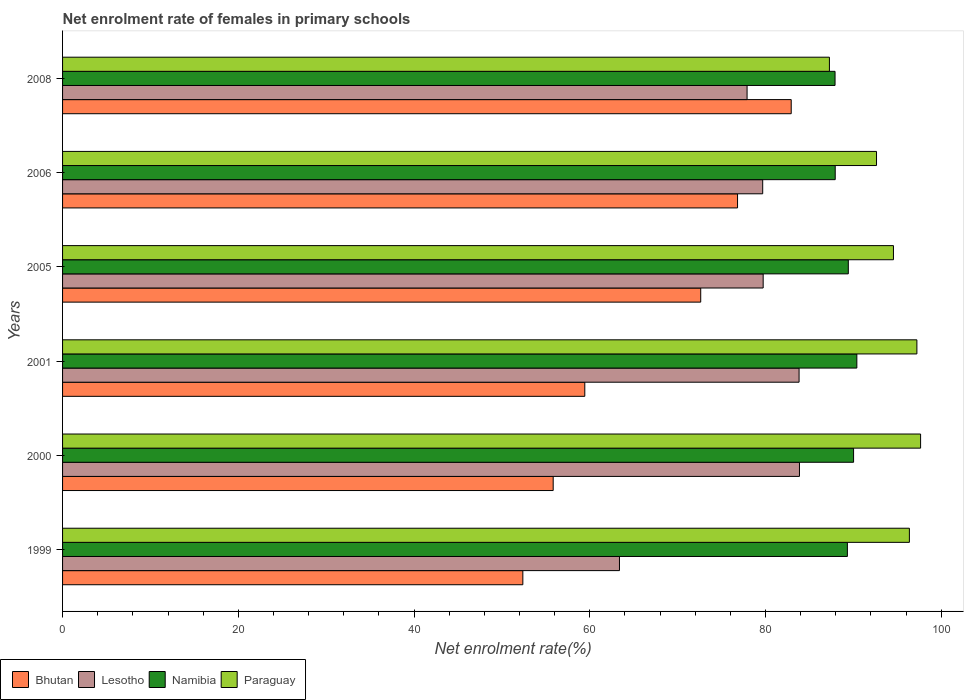How many different coloured bars are there?
Provide a succinct answer. 4. Are the number of bars on each tick of the Y-axis equal?
Provide a short and direct response. Yes. What is the label of the 6th group of bars from the top?
Make the answer very short. 1999. What is the net enrolment rate of females in primary schools in Paraguay in 1999?
Provide a succinct answer. 96.38. Across all years, what is the maximum net enrolment rate of females in primary schools in Namibia?
Make the answer very short. 90.4. Across all years, what is the minimum net enrolment rate of females in primary schools in Lesotho?
Make the answer very short. 63.38. In which year was the net enrolment rate of females in primary schools in Namibia maximum?
Keep it short and to the point. 2001. What is the total net enrolment rate of females in primary schools in Namibia in the graph?
Provide a short and direct response. 535.02. What is the difference between the net enrolment rate of females in primary schools in Bhutan in 1999 and that in 2001?
Offer a terse response. -7.05. What is the difference between the net enrolment rate of females in primary schools in Bhutan in 2006 and the net enrolment rate of females in primary schools in Paraguay in 2000?
Make the answer very short. -20.83. What is the average net enrolment rate of females in primary schools in Lesotho per year?
Your answer should be very brief. 78.07. In the year 1999, what is the difference between the net enrolment rate of females in primary schools in Bhutan and net enrolment rate of females in primary schools in Paraguay?
Your response must be concise. -43.99. What is the ratio of the net enrolment rate of females in primary schools in Paraguay in 2000 to that in 2006?
Offer a very short reply. 1.05. Is the difference between the net enrolment rate of females in primary schools in Bhutan in 2000 and 2001 greater than the difference between the net enrolment rate of females in primary schools in Paraguay in 2000 and 2001?
Your response must be concise. No. What is the difference between the highest and the second highest net enrolment rate of females in primary schools in Bhutan?
Offer a terse response. 6.11. What is the difference between the highest and the lowest net enrolment rate of females in primary schools in Bhutan?
Your answer should be compact. 30.54. Is the sum of the net enrolment rate of females in primary schools in Lesotho in 2000 and 2005 greater than the maximum net enrolment rate of females in primary schools in Paraguay across all years?
Give a very brief answer. Yes. Is it the case that in every year, the sum of the net enrolment rate of females in primary schools in Namibia and net enrolment rate of females in primary schools in Bhutan is greater than the sum of net enrolment rate of females in primary schools in Lesotho and net enrolment rate of females in primary schools in Paraguay?
Give a very brief answer. No. What does the 2nd bar from the top in 2006 represents?
Provide a short and direct response. Namibia. What does the 4th bar from the bottom in 2000 represents?
Offer a very short reply. Paraguay. How many years are there in the graph?
Give a very brief answer. 6. Are the values on the major ticks of X-axis written in scientific E-notation?
Your answer should be compact. No. Does the graph contain any zero values?
Keep it short and to the point. No. Where does the legend appear in the graph?
Make the answer very short. Bottom left. What is the title of the graph?
Provide a short and direct response. Net enrolment rate of females in primary schools. What is the label or title of the X-axis?
Provide a succinct answer. Net enrolment rate(%). What is the Net enrolment rate(%) of Bhutan in 1999?
Give a very brief answer. 52.39. What is the Net enrolment rate(%) in Lesotho in 1999?
Your answer should be very brief. 63.38. What is the Net enrolment rate(%) in Namibia in 1999?
Offer a very short reply. 89.32. What is the Net enrolment rate(%) of Paraguay in 1999?
Ensure brevity in your answer.  96.38. What is the Net enrolment rate(%) of Bhutan in 2000?
Keep it short and to the point. 55.84. What is the Net enrolment rate(%) of Lesotho in 2000?
Offer a very short reply. 83.87. What is the Net enrolment rate(%) in Namibia in 2000?
Keep it short and to the point. 90.03. What is the Net enrolment rate(%) of Paraguay in 2000?
Give a very brief answer. 97.65. What is the Net enrolment rate(%) of Bhutan in 2001?
Give a very brief answer. 59.44. What is the Net enrolment rate(%) of Lesotho in 2001?
Your answer should be compact. 83.82. What is the Net enrolment rate(%) of Namibia in 2001?
Offer a terse response. 90.4. What is the Net enrolment rate(%) in Paraguay in 2001?
Your answer should be compact. 97.23. What is the Net enrolment rate(%) of Bhutan in 2005?
Offer a terse response. 72.63. What is the Net enrolment rate(%) of Lesotho in 2005?
Your response must be concise. 79.74. What is the Net enrolment rate(%) of Namibia in 2005?
Provide a short and direct response. 89.43. What is the Net enrolment rate(%) of Paraguay in 2005?
Offer a very short reply. 94.56. What is the Net enrolment rate(%) of Bhutan in 2006?
Provide a short and direct response. 76.82. What is the Net enrolment rate(%) of Lesotho in 2006?
Give a very brief answer. 79.68. What is the Net enrolment rate(%) in Namibia in 2006?
Your response must be concise. 87.94. What is the Net enrolment rate(%) of Paraguay in 2006?
Ensure brevity in your answer.  92.64. What is the Net enrolment rate(%) in Bhutan in 2008?
Offer a very short reply. 82.93. What is the Net enrolment rate(%) of Lesotho in 2008?
Keep it short and to the point. 77.91. What is the Net enrolment rate(%) in Namibia in 2008?
Make the answer very short. 87.92. What is the Net enrolment rate(%) in Paraguay in 2008?
Your response must be concise. 87.28. Across all years, what is the maximum Net enrolment rate(%) in Bhutan?
Provide a succinct answer. 82.93. Across all years, what is the maximum Net enrolment rate(%) in Lesotho?
Your answer should be compact. 83.87. Across all years, what is the maximum Net enrolment rate(%) in Namibia?
Provide a short and direct response. 90.4. Across all years, what is the maximum Net enrolment rate(%) in Paraguay?
Your response must be concise. 97.65. Across all years, what is the minimum Net enrolment rate(%) of Bhutan?
Your response must be concise. 52.39. Across all years, what is the minimum Net enrolment rate(%) in Lesotho?
Offer a very short reply. 63.38. Across all years, what is the minimum Net enrolment rate(%) in Namibia?
Offer a very short reply. 87.92. Across all years, what is the minimum Net enrolment rate(%) in Paraguay?
Your response must be concise. 87.28. What is the total Net enrolment rate(%) of Bhutan in the graph?
Ensure brevity in your answer.  400.04. What is the total Net enrolment rate(%) of Lesotho in the graph?
Your answer should be very brief. 468.4. What is the total Net enrolment rate(%) of Namibia in the graph?
Ensure brevity in your answer.  535.02. What is the total Net enrolment rate(%) in Paraguay in the graph?
Your answer should be very brief. 565.74. What is the difference between the Net enrolment rate(%) in Bhutan in 1999 and that in 2000?
Your answer should be very brief. -3.45. What is the difference between the Net enrolment rate(%) of Lesotho in 1999 and that in 2000?
Provide a short and direct response. -20.48. What is the difference between the Net enrolment rate(%) in Namibia in 1999 and that in 2000?
Make the answer very short. -0.7. What is the difference between the Net enrolment rate(%) in Paraguay in 1999 and that in 2000?
Your response must be concise. -1.27. What is the difference between the Net enrolment rate(%) in Bhutan in 1999 and that in 2001?
Provide a short and direct response. -7.05. What is the difference between the Net enrolment rate(%) of Lesotho in 1999 and that in 2001?
Ensure brevity in your answer.  -20.44. What is the difference between the Net enrolment rate(%) of Namibia in 1999 and that in 2001?
Ensure brevity in your answer.  -1.08. What is the difference between the Net enrolment rate(%) of Paraguay in 1999 and that in 2001?
Make the answer very short. -0.85. What is the difference between the Net enrolment rate(%) of Bhutan in 1999 and that in 2005?
Give a very brief answer. -20.24. What is the difference between the Net enrolment rate(%) of Lesotho in 1999 and that in 2005?
Offer a terse response. -16.35. What is the difference between the Net enrolment rate(%) of Namibia in 1999 and that in 2005?
Provide a short and direct response. -0.1. What is the difference between the Net enrolment rate(%) in Paraguay in 1999 and that in 2005?
Keep it short and to the point. 1.81. What is the difference between the Net enrolment rate(%) in Bhutan in 1999 and that in 2006?
Ensure brevity in your answer.  -24.43. What is the difference between the Net enrolment rate(%) in Lesotho in 1999 and that in 2006?
Make the answer very short. -16.3. What is the difference between the Net enrolment rate(%) in Namibia in 1999 and that in 2006?
Provide a short and direct response. 1.39. What is the difference between the Net enrolment rate(%) in Paraguay in 1999 and that in 2006?
Keep it short and to the point. 3.74. What is the difference between the Net enrolment rate(%) in Bhutan in 1999 and that in 2008?
Ensure brevity in your answer.  -30.54. What is the difference between the Net enrolment rate(%) of Lesotho in 1999 and that in 2008?
Keep it short and to the point. -14.52. What is the difference between the Net enrolment rate(%) in Namibia in 1999 and that in 2008?
Offer a very short reply. 1.41. What is the difference between the Net enrolment rate(%) of Paraguay in 1999 and that in 2008?
Provide a short and direct response. 9.1. What is the difference between the Net enrolment rate(%) of Bhutan in 2000 and that in 2001?
Your answer should be compact. -3.6. What is the difference between the Net enrolment rate(%) in Lesotho in 2000 and that in 2001?
Give a very brief answer. 0.04. What is the difference between the Net enrolment rate(%) of Namibia in 2000 and that in 2001?
Your answer should be compact. -0.37. What is the difference between the Net enrolment rate(%) in Paraguay in 2000 and that in 2001?
Offer a very short reply. 0.42. What is the difference between the Net enrolment rate(%) in Bhutan in 2000 and that in 2005?
Give a very brief answer. -16.79. What is the difference between the Net enrolment rate(%) in Lesotho in 2000 and that in 2005?
Provide a succinct answer. 4.13. What is the difference between the Net enrolment rate(%) of Namibia in 2000 and that in 2005?
Your response must be concise. 0.6. What is the difference between the Net enrolment rate(%) of Paraguay in 2000 and that in 2005?
Your response must be concise. 3.09. What is the difference between the Net enrolment rate(%) of Bhutan in 2000 and that in 2006?
Provide a succinct answer. -20.98. What is the difference between the Net enrolment rate(%) in Lesotho in 2000 and that in 2006?
Provide a succinct answer. 4.18. What is the difference between the Net enrolment rate(%) in Namibia in 2000 and that in 2006?
Offer a very short reply. 2.09. What is the difference between the Net enrolment rate(%) of Paraguay in 2000 and that in 2006?
Your response must be concise. 5.02. What is the difference between the Net enrolment rate(%) of Bhutan in 2000 and that in 2008?
Provide a short and direct response. -27.09. What is the difference between the Net enrolment rate(%) of Lesotho in 2000 and that in 2008?
Your answer should be very brief. 5.96. What is the difference between the Net enrolment rate(%) of Namibia in 2000 and that in 2008?
Provide a succinct answer. 2.11. What is the difference between the Net enrolment rate(%) of Paraguay in 2000 and that in 2008?
Provide a short and direct response. 10.38. What is the difference between the Net enrolment rate(%) of Bhutan in 2001 and that in 2005?
Offer a terse response. -13.19. What is the difference between the Net enrolment rate(%) of Lesotho in 2001 and that in 2005?
Your answer should be very brief. 4.09. What is the difference between the Net enrolment rate(%) of Namibia in 2001 and that in 2005?
Your answer should be compact. 0.97. What is the difference between the Net enrolment rate(%) in Paraguay in 2001 and that in 2005?
Give a very brief answer. 2.67. What is the difference between the Net enrolment rate(%) in Bhutan in 2001 and that in 2006?
Ensure brevity in your answer.  -17.38. What is the difference between the Net enrolment rate(%) of Lesotho in 2001 and that in 2006?
Your answer should be very brief. 4.14. What is the difference between the Net enrolment rate(%) of Namibia in 2001 and that in 2006?
Give a very brief answer. 2.46. What is the difference between the Net enrolment rate(%) of Paraguay in 2001 and that in 2006?
Your answer should be compact. 4.59. What is the difference between the Net enrolment rate(%) of Bhutan in 2001 and that in 2008?
Offer a terse response. -23.49. What is the difference between the Net enrolment rate(%) in Lesotho in 2001 and that in 2008?
Provide a succinct answer. 5.92. What is the difference between the Net enrolment rate(%) in Namibia in 2001 and that in 2008?
Your response must be concise. 2.48. What is the difference between the Net enrolment rate(%) in Paraguay in 2001 and that in 2008?
Make the answer very short. 9.95. What is the difference between the Net enrolment rate(%) of Bhutan in 2005 and that in 2006?
Your answer should be very brief. -4.19. What is the difference between the Net enrolment rate(%) in Lesotho in 2005 and that in 2006?
Offer a terse response. 0.05. What is the difference between the Net enrolment rate(%) in Namibia in 2005 and that in 2006?
Give a very brief answer. 1.49. What is the difference between the Net enrolment rate(%) in Paraguay in 2005 and that in 2006?
Offer a terse response. 1.93. What is the difference between the Net enrolment rate(%) in Bhutan in 2005 and that in 2008?
Make the answer very short. -10.3. What is the difference between the Net enrolment rate(%) of Lesotho in 2005 and that in 2008?
Your answer should be compact. 1.83. What is the difference between the Net enrolment rate(%) in Namibia in 2005 and that in 2008?
Ensure brevity in your answer.  1.51. What is the difference between the Net enrolment rate(%) of Paraguay in 2005 and that in 2008?
Offer a terse response. 7.29. What is the difference between the Net enrolment rate(%) of Bhutan in 2006 and that in 2008?
Your response must be concise. -6.11. What is the difference between the Net enrolment rate(%) in Lesotho in 2006 and that in 2008?
Your answer should be compact. 1.78. What is the difference between the Net enrolment rate(%) of Namibia in 2006 and that in 2008?
Your response must be concise. 0.02. What is the difference between the Net enrolment rate(%) of Paraguay in 2006 and that in 2008?
Ensure brevity in your answer.  5.36. What is the difference between the Net enrolment rate(%) in Bhutan in 1999 and the Net enrolment rate(%) in Lesotho in 2000?
Offer a very short reply. -31.48. What is the difference between the Net enrolment rate(%) of Bhutan in 1999 and the Net enrolment rate(%) of Namibia in 2000?
Provide a succinct answer. -37.64. What is the difference between the Net enrolment rate(%) of Bhutan in 1999 and the Net enrolment rate(%) of Paraguay in 2000?
Offer a terse response. -45.27. What is the difference between the Net enrolment rate(%) of Lesotho in 1999 and the Net enrolment rate(%) of Namibia in 2000?
Provide a succinct answer. -26.64. What is the difference between the Net enrolment rate(%) of Lesotho in 1999 and the Net enrolment rate(%) of Paraguay in 2000?
Your answer should be very brief. -34.27. What is the difference between the Net enrolment rate(%) of Namibia in 1999 and the Net enrolment rate(%) of Paraguay in 2000?
Your answer should be compact. -8.33. What is the difference between the Net enrolment rate(%) of Bhutan in 1999 and the Net enrolment rate(%) of Lesotho in 2001?
Keep it short and to the point. -31.44. What is the difference between the Net enrolment rate(%) of Bhutan in 1999 and the Net enrolment rate(%) of Namibia in 2001?
Keep it short and to the point. -38.01. What is the difference between the Net enrolment rate(%) of Bhutan in 1999 and the Net enrolment rate(%) of Paraguay in 2001?
Offer a terse response. -44.85. What is the difference between the Net enrolment rate(%) of Lesotho in 1999 and the Net enrolment rate(%) of Namibia in 2001?
Your answer should be compact. -27.02. What is the difference between the Net enrolment rate(%) in Lesotho in 1999 and the Net enrolment rate(%) in Paraguay in 2001?
Offer a very short reply. -33.85. What is the difference between the Net enrolment rate(%) in Namibia in 1999 and the Net enrolment rate(%) in Paraguay in 2001?
Your answer should be very brief. -7.91. What is the difference between the Net enrolment rate(%) of Bhutan in 1999 and the Net enrolment rate(%) of Lesotho in 2005?
Offer a very short reply. -27.35. What is the difference between the Net enrolment rate(%) of Bhutan in 1999 and the Net enrolment rate(%) of Namibia in 2005?
Your answer should be compact. -37.04. What is the difference between the Net enrolment rate(%) of Bhutan in 1999 and the Net enrolment rate(%) of Paraguay in 2005?
Ensure brevity in your answer.  -42.18. What is the difference between the Net enrolment rate(%) of Lesotho in 1999 and the Net enrolment rate(%) of Namibia in 2005?
Your response must be concise. -26.04. What is the difference between the Net enrolment rate(%) in Lesotho in 1999 and the Net enrolment rate(%) in Paraguay in 2005?
Ensure brevity in your answer.  -31.18. What is the difference between the Net enrolment rate(%) of Namibia in 1999 and the Net enrolment rate(%) of Paraguay in 2005?
Your response must be concise. -5.24. What is the difference between the Net enrolment rate(%) of Bhutan in 1999 and the Net enrolment rate(%) of Lesotho in 2006?
Your answer should be very brief. -27.3. What is the difference between the Net enrolment rate(%) in Bhutan in 1999 and the Net enrolment rate(%) in Namibia in 2006?
Your response must be concise. -35.55. What is the difference between the Net enrolment rate(%) of Bhutan in 1999 and the Net enrolment rate(%) of Paraguay in 2006?
Your answer should be compact. -40.25. What is the difference between the Net enrolment rate(%) in Lesotho in 1999 and the Net enrolment rate(%) in Namibia in 2006?
Ensure brevity in your answer.  -24.55. What is the difference between the Net enrolment rate(%) in Lesotho in 1999 and the Net enrolment rate(%) in Paraguay in 2006?
Offer a very short reply. -29.26. What is the difference between the Net enrolment rate(%) of Namibia in 1999 and the Net enrolment rate(%) of Paraguay in 2006?
Your answer should be very brief. -3.32. What is the difference between the Net enrolment rate(%) in Bhutan in 1999 and the Net enrolment rate(%) in Lesotho in 2008?
Your answer should be very brief. -25.52. What is the difference between the Net enrolment rate(%) in Bhutan in 1999 and the Net enrolment rate(%) in Namibia in 2008?
Your answer should be very brief. -35.53. What is the difference between the Net enrolment rate(%) in Bhutan in 1999 and the Net enrolment rate(%) in Paraguay in 2008?
Offer a terse response. -34.89. What is the difference between the Net enrolment rate(%) of Lesotho in 1999 and the Net enrolment rate(%) of Namibia in 2008?
Your answer should be very brief. -24.53. What is the difference between the Net enrolment rate(%) in Lesotho in 1999 and the Net enrolment rate(%) in Paraguay in 2008?
Provide a succinct answer. -23.89. What is the difference between the Net enrolment rate(%) in Namibia in 1999 and the Net enrolment rate(%) in Paraguay in 2008?
Offer a very short reply. 2.05. What is the difference between the Net enrolment rate(%) in Bhutan in 2000 and the Net enrolment rate(%) in Lesotho in 2001?
Offer a terse response. -27.99. What is the difference between the Net enrolment rate(%) in Bhutan in 2000 and the Net enrolment rate(%) in Namibia in 2001?
Your answer should be very brief. -34.56. What is the difference between the Net enrolment rate(%) in Bhutan in 2000 and the Net enrolment rate(%) in Paraguay in 2001?
Provide a succinct answer. -41.39. What is the difference between the Net enrolment rate(%) in Lesotho in 2000 and the Net enrolment rate(%) in Namibia in 2001?
Keep it short and to the point. -6.53. What is the difference between the Net enrolment rate(%) in Lesotho in 2000 and the Net enrolment rate(%) in Paraguay in 2001?
Your answer should be compact. -13.36. What is the difference between the Net enrolment rate(%) in Namibia in 2000 and the Net enrolment rate(%) in Paraguay in 2001?
Ensure brevity in your answer.  -7.21. What is the difference between the Net enrolment rate(%) in Bhutan in 2000 and the Net enrolment rate(%) in Lesotho in 2005?
Provide a short and direct response. -23.9. What is the difference between the Net enrolment rate(%) in Bhutan in 2000 and the Net enrolment rate(%) in Namibia in 2005?
Make the answer very short. -33.59. What is the difference between the Net enrolment rate(%) in Bhutan in 2000 and the Net enrolment rate(%) in Paraguay in 2005?
Your answer should be very brief. -38.73. What is the difference between the Net enrolment rate(%) of Lesotho in 2000 and the Net enrolment rate(%) of Namibia in 2005?
Your answer should be very brief. -5.56. What is the difference between the Net enrolment rate(%) in Lesotho in 2000 and the Net enrolment rate(%) in Paraguay in 2005?
Offer a very short reply. -10.7. What is the difference between the Net enrolment rate(%) in Namibia in 2000 and the Net enrolment rate(%) in Paraguay in 2005?
Make the answer very short. -4.54. What is the difference between the Net enrolment rate(%) of Bhutan in 2000 and the Net enrolment rate(%) of Lesotho in 2006?
Your answer should be compact. -23.85. What is the difference between the Net enrolment rate(%) of Bhutan in 2000 and the Net enrolment rate(%) of Namibia in 2006?
Make the answer very short. -32.1. What is the difference between the Net enrolment rate(%) of Bhutan in 2000 and the Net enrolment rate(%) of Paraguay in 2006?
Your response must be concise. -36.8. What is the difference between the Net enrolment rate(%) in Lesotho in 2000 and the Net enrolment rate(%) in Namibia in 2006?
Offer a very short reply. -4.07. What is the difference between the Net enrolment rate(%) of Lesotho in 2000 and the Net enrolment rate(%) of Paraguay in 2006?
Make the answer very short. -8.77. What is the difference between the Net enrolment rate(%) in Namibia in 2000 and the Net enrolment rate(%) in Paraguay in 2006?
Give a very brief answer. -2.61. What is the difference between the Net enrolment rate(%) in Bhutan in 2000 and the Net enrolment rate(%) in Lesotho in 2008?
Provide a short and direct response. -22.07. What is the difference between the Net enrolment rate(%) in Bhutan in 2000 and the Net enrolment rate(%) in Namibia in 2008?
Your answer should be compact. -32.08. What is the difference between the Net enrolment rate(%) of Bhutan in 2000 and the Net enrolment rate(%) of Paraguay in 2008?
Provide a succinct answer. -31.44. What is the difference between the Net enrolment rate(%) of Lesotho in 2000 and the Net enrolment rate(%) of Namibia in 2008?
Offer a terse response. -4.05. What is the difference between the Net enrolment rate(%) of Lesotho in 2000 and the Net enrolment rate(%) of Paraguay in 2008?
Ensure brevity in your answer.  -3.41. What is the difference between the Net enrolment rate(%) in Namibia in 2000 and the Net enrolment rate(%) in Paraguay in 2008?
Your answer should be very brief. 2.75. What is the difference between the Net enrolment rate(%) in Bhutan in 2001 and the Net enrolment rate(%) in Lesotho in 2005?
Provide a succinct answer. -20.3. What is the difference between the Net enrolment rate(%) in Bhutan in 2001 and the Net enrolment rate(%) in Namibia in 2005?
Provide a succinct answer. -29.99. What is the difference between the Net enrolment rate(%) in Bhutan in 2001 and the Net enrolment rate(%) in Paraguay in 2005?
Your answer should be compact. -35.13. What is the difference between the Net enrolment rate(%) in Lesotho in 2001 and the Net enrolment rate(%) in Namibia in 2005?
Offer a very short reply. -5.6. What is the difference between the Net enrolment rate(%) in Lesotho in 2001 and the Net enrolment rate(%) in Paraguay in 2005?
Give a very brief answer. -10.74. What is the difference between the Net enrolment rate(%) of Namibia in 2001 and the Net enrolment rate(%) of Paraguay in 2005?
Your answer should be compact. -4.17. What is the difference between the Net enrolment rate(%) in Bhutan in 2001 and the Net enrolment rate(%) in Lesotho in 2006?
Your response must be concise. -20.25. What is the difference between the Net enrolment rate(%) in Bhutan in 2001 and the Net enrolment rate(%) in Namibia in 2006?
Your response must be concise. -28.5. What is the difference between the Net enrolment rate(%) of Bhutan in 2001 and the Net enrolment rate(%) of Paraguay in 2006?
Your answer should be compact. -33.2. What is the difference between the Net enrolment rate(%) in Lesotho in 2001 and the Net enrolment rate(%) in Namibia in 2006?
Your answer should be very brief. -4.11. What is the difference between the Net enrolment rate(%) in Lesotho in 2001 and the Net enrolment rate(%) in Paraguay in 2006?
Provide a short and direct response. -8.81. What is the difference between the Net enrolment rate(%) in Namibia in 2001 and the Net enrolment rate(%) in Paraguay in 2006?
Provide a short and direct response. -2.24. What is the difference between the Net enrolment rate(%) in Bhutan in 2001 and the Net enrolment rate(%) in Lesotho in 2008?
Your response must be concise. -18.47. What is the difference between the Net enrolment rate(%) in Bhutan in 2001 and the Net enrolment rate(%) in Namibia in 2008?
Your response must be concise. -28.48. What is the difference between the Net enrolment rate(%) in Bhutan in 2001 and the Net enrolment rate(%) in Paraguay in 2008?
Keep it short and to the point. -27.84. What is the difference between the Net enrolment rate(%) in Lesotho in 2001 and the Net enrolment rate(%) in Namibia in 2008?
Offer a terse response. -4.09. What is the difference between the Net enrolment rate(%) of Lesotho in 2001 and the Net enrolment rate(%) of Paraguay in 2008?
Your answer should be compact. -3.45. What is the difference between the Net enrolment rate(%) in Namibia in 2001 and the Net enrolment rate(%) in Paraguay in 2008?
Your answer should be very brief. 3.12. What is the difference between the Net enrolment rate(%) of Bhutan in 2005 and the Net enrolment rate(%) of Lesotho in 2006?
Give a very brief answer. -7.05. What is the difference between the Net enrolment rate(%) of Bhutan in 2005 and the Net enrolment rate(%) of Namibia in 2006?
Give a very brief answer. -15.31. What is the difference between the Net enrolment rate(%) in Bhutan in 2005 and the Net enrolment rate(%) in Paraguay in 2006?
Your response must be concise. -20.01. What is the difference between the Net enrolment rate(%) of Lesotho in 2005 and the Net enrolment rate(%) of Namibia in 2006?
Your answer should be very brief. -8.2. What is the difference between the Net enrolment rate(%) in Lesotho in 2005 and the Net enrolment rate(%) in Paraguay in 2006?
Offer a very short reply. -12.9. What is the difference between the Net enrolment rate(%) of Namibia in 2005 and the Net enrolment rate(%) of Paraguay in 2006?
Give a very brief answer. -3.21. What is the difference between the Net enrolment rate(%) in Bhutan in 2005 and the Net enrolment rate(%) in Lesotho in 2008?
Ensure brevity in your answer.  -5.28. What is the difference between the Net enrolment rate(%) of Bhutan in 2005 and the Net enrolment rate(%) of Namibia in 2008?
Offer a very short reply. -15.29. What is the difference between the Net enrolment rate(%) in Bhutan in 2005 and the Net enrolment rate(%) in Paraguay in 2008?
Make the answer very short. -14.65. What is the difference between the Net enrolment rate(%) in Lesotho in 2005 and the Net enrolment rate(%) in Namibia in 2008?
Offer a terse response. -8.18. What is the difference between the Net enrolment rate(%) in Lesotho in 2005 and the Net enrolment rate(%) in Paraguay in 2008?
Give a very brief answer. -7.54. What is the difference between the Net enrolment rate(%) in Namibia in 2005 and the Net enrolment rate(%) in Paraguay in 2008?
Provide a short and direct response. 2.15. What is the difference between the Net enrolment rate(%) in Bhutan in 2006 and the Net enrolment rate(%) in Lesotho in 2008?
Your response must be concise. -1.09. What is the difference between the Net enrolment rate(%) in Bhutan in 2006 and the Net enrolment rate(%) in Namibia in 2008?
Your answer should be very brief. -11.1. What is the difference between the Net enrolment rate(%) in Bhutan in 2006 and the Net enrolment rate(%) in Paraguay in 2008?
Offer a very short reply. -10.46. What is the difference between the Net enrolment rate(%) in Lesotho in 2006 and the Net enrolment rate(%) in Namibia in 2008?
Offer a terse response. -8.23. What is the difference between the Net enrolment rate(%) of Lesotho in 2006 and the Net enrolment rate(%) of Paraguay in 2008?
Your answer should be compact. -7.59. What is the difference between the Net enrolment rate(%) in Namibia in 2006 and the Net enrolment rate(%) in Paraguay in 2008?
Your answer should be compact. 0.66. What is the average Net enrolment rate(%) in Bhutan per year?
Offer a very short reply. 66.67. What is the average Net enrolment rate(%) of Lesotho per year?
Offer a very short reply. 78.07. What is the average Net enrolment rate(%) in Namibia per year?
Ensure brevity in your answer.  89.17. What is the average Net enrolment rate(%) of Paraguay per year?
Ensure brevity in your answer.  94.29. In the year 1999, what is the difference between the Net enrolment rate(%) of Bhutan and Net enrolment rate(%) of Lesotho?
Offer a very short reply. -11. In the year 1999, what is the difference between the Net enrolment rate(%) of Bhutan and Net enrolment rate(%) of Namibia?
Make the answer very short. -36.94. In the year 1999, what is the difference between the Net enrolment rate(%) of Bhutan and Net enrolment rate(%) of Paraguay?
Provide a short and direct response. -43.99. In the year 1999, what is the difference between the Net enrolment rate(%) of Lesotho and Net enrolment rate(%) of Namibia?
Give a very brief answer. -25.94. In the year 1999, what is the difference between the Net enrolment rate(%) of Lesotho and Net enrolment rate(%) of Paraguay?
Provide a short and direct response. -33. In the year 1999, what is the difference between the Net enrolment rate(%) of Namibia and Net enrolment rate(%) of Paraguay?
Make the answer very short. -7.06. In the year 2000, what is the difference between the Net enrolment rate(%) of Bhutan and Net enrolment rate(%) of Lesotho?
Offer a very short reply. -28.03. In the year 2000, what is the difference between the Net enrolment rate(%) of Bhutan and Net enrolment rate(%) of Namibia?
Your answer should be very brief. -34.19. In the year 2000, what is the difference between the Net enrolment rate(%) of Bhutan and Net enrolment rate(%) of Paraguay?
Offer a terse response. -41.82. In the year 2000, what is the difference between the Net enrolment rate(%) of Lesotho and Net enrolment rate(%) of Namibia?
Keep it short and to the point. -6.16. In the year 2000, what is the difference between the Net enrolment rate(%) in Lesotho and Net enrolment rate(%) in Paraguay?
Offer a terse response. -13.79. In the year 2000, what is the difference between the Net enrolment rate(%) in Namibia and Net enrolment rate(%) in Paraguay?
Your answer should be compact. -7.63. In the year 2001, what is the difference between the Net enrolment rate(%) in Bhutan and Net enrolment rate(%) in Lesotho?
Provide a short and direct response. -24.39. In the year 2001, what is the difference between the Net enrolment rate(%) of Bhutan and Net enrolment rate(%) of Namibia?
Make the answer very short. -30.96. In the year 2001, what is the difference between the Net enrolment rate(%) of Bhutan and Net enrolment rate(%) of Paraguay?
Provide a short and direct response. -37.8. In the year 2001, what is the difference between the Net enrolment rate(%) of Lesotho and Net enrolment rate(%) of Namibia?
Your response must be concise. -6.57. In the year 2001, what is the difference between the Net enrolment rate(%) of Lesotho and Net enrolment rate(%) of Paraguay?
Offer a very short reply. -13.41. In the year 2001, what is the difference between the Net enrolment rate(%) of Namibia and Net enrolment rate(%) of Paraguay?
Keep it short and to the point. -6.83. In the year 2005, what is the difference between the Net enrolment rate(%) of Bhutan and Net enrolment rate(%) of Lesotho?
Provide a short and direct response. -7.11. In the year 2005, what is the difference between the Net enrolment rate(%) in Bhutan and Net enrolment rate(%) in Namibia?
Offer a terse response. -16.8. In the year 2005, what is the difference between the Net enrolment rate(%) in Bhutan and Net enrolment rate(%) in Paraguay?
Offer a terse response. -21.93. In the year 2005, what is the difference between the Net enrolment rate(%) of Lesotho and Net enrolment rate(%) of Namibia?
Ensure brevity in your answer.  -9.69. In the year 2005, what is the difference between the Net enrolment rate(%) of Lesotho and Net enrolment rate(%) of Paraguay?
Your answer should be compact. -14.83. In the year 2005, what is the difference between the Net enrolment rate(%) in Namibia and Net enrolment rate(%) in Paraguay?
Offer a terse response. -5.14. In the year 2006, what is the difference between the Net enrolment rate(%) of Bhutan and Net enrolment rate(%) of Lesotho?
Give a very brief answer. -2.86. In the year 2006, what is the difference between the Net enrolment rate(%) in Bhutan and Net enrolment rate(%) in Namibia?
Make the answer very short. -11.12. In the year 2006, what is the difference between the Net enrolment rate(%) in Bhutan and Net enrolment rate(%) in Paraguay?
Your answer should be compact. -15.82. In the year 2006, what is the difference between the Net enrolment rate(%) of Lesotho and Net enrolment rate(%) of Namibia?
Keep it short and to the point. -8.25. In the year 2006, what is the difference between the Net enrolment rate(%) of Lesotho and Net enrolment rate(%) of Paraguay?
Provide a succinct answer. -12.95. In the year 2006, what is the difference between the Net enrolment rate(%) in Namibia and Net enrolment rate(%) in Paraguay?
Make the answer very short. -4.7. In the year 2008, what is the difference between the Net enrolment rate(%) in Bhutan and Net enrolment rate(%) in Lesotho?
Offer a terse response. 5.02. In the year 2008, what is the difference between the Net enrolment rate(%) in Bhutan and Net enrolment rate(%) in Namibia?
Give a very brief answer. -4.99. In the year 2008, what is the difference between the Net enrolment rate(%) in Bhutan and Net enrolment rate(%) in Paraguay?
Ensure brevity in your answer.  -4.35. In the year 2008, what is the difference between the Net enrolment rate(%) in Lesotho and Net enrolment rate(%) in Namibia?
Make the answer very short. -10.01. In the year 2008, what is the difference between the Net enrolment rate(%) in Lesotho and Net enrolment rate(%) in Paraguay?
Provide a short and direct response. -9.37. In the year 2008, what is the difference between the Net enrolment rate(%) in Namibia and Net enrolment rate(%) in Paraguay?
Your answer should be very brief. 0.64. What is the ratio of the Net enrolment rate(%) in Bhutan in 1999 to that in 2000?
Offer a terse response. 0.94. What is the ratio of the Net enrolment rate(%) of Lesotho in 1999 to that in 2000?
Give a very brief answer. 0.76. What is the ratio of the Net enrolment rate(%) of Namibia in 1999 to that in 2000?
Keep it short and to the point. 0.99. What is the ratio of the Net enrolment rate(%) in Paraguay in 1999 to that in 2000?
Your answer should be very brief. 0.99. What is the ratio of the Net enrolment rate(%) in Bhutan in 1999 to that in 2001?
Offer a terse response. 0.88. What is the ratio of the Net enrolment rate(%) of Lesotho in 1999 to that in 2001?
Provide a succinct answer. 0.76. What is the ratio of the Net enrolment rate(%) of Paraguay in 1999 to that in 2001?
Make the answer very short. 0.99. What is the ratio of the Net enrolment rate(%) in Bhutan in 1999 to that in 2005?
Provide a succinct answer. 0.72. What is the ratio of the Net enrolment rate(%) in Lesotho in 1999 to that in 2005?
Make the answer very short. 0.79. What is the ratio of the Net enrolment rate(%) in Paraguay in 1999 to that in 2005?
Give a very brief answer. 1.02. What is the ratio of the Net enrolment rate(%) in Bhutan in 1999 to that in 2006?
Give a very brief answer. 0.68. What is the ratio of the Net enrolment rate(%) of Lesotho in 1999 to that in 2006?
Provide a short and direct response. 0.8. What is the ratio of the Net enrolment rate(%) in Namibia in 1999 to that in 2006?
Provide a short and direct response. 1.02. What is the ratio of the Net enrolment rate(%) of Paraguay in 1999 to that in 2006?
Provide a short and direct response. 1.04. What is the ratio of the Net enrolment rate(%) in Bhutan in 1999 to that in 2008?
Offer a very short reply. 0.63. What is the ratio of the Net enrolment rate(%) in Lesotho in 1999 to that in 2008?
Provide a short and direct response. 0.81. What is the ratio of the Net enrolment rate(%) of Paraguay in 1999 to that in 2008?
Ensure brevity in your answer.  1.1. What is the ratio of the Net enrolment rate(%) of Bhutan in 2000 to that in 2001?
Provide a succinct answer. 0.94. What is the ratio of the Net enrolment rate(%) of Lesotho in 2000 to that in 2001?
Keep it short and to the point. 1. What is the ratio of the Net enrolment rate(%) in Bhutan in 2000 to that in 2005?
Provide a succinct answer. 0.77. What is the ratio of the Net enrolment rate(%) in Lesotho in 2000 to that in 2005?
Offer a terse response. 1.05. What is the ratio of the Net enrolment rate(%) of Paraguay in 2000 to that in 2005?
Provide a short and direct response. 1.03. What is the ratio of the Net enrolment rate(%) of Bhutan in 2000 to that in 2006?
Make the answer very short. 0.73. What is the ratio of the Net enrolment rate(%) in Lesotho in 2000 to that in 2006?
Offer a terse response. 1.05. What is the ratio of the Net enrolment rate(%) in Namibia in 2000 to that in 2006?
Make the answer very short. 1.02. What is the ratio of the Net enrolment rate(%) of Paraguay in 2000 to that in 2006?
Your answer should be very brief. 1.05. What is the ratio of the Net enrolment rate(%) in Bhutan in 2000 to that in 2008?
Make the answer very short. 0.67. What is the ratio of the Net enrolment rate(%) in Lesotho in 2000 to that in 2008?
Your response must be concise. 1.08. What is the ratio of the Net enrolment rate(%) in Namibia in 2000 to that in 2008?
Offer a very short reply. 1.02. What is the ratio of the Net enrolment rate(%) in Paraguay in 2000 to that in 2008?
Your answer should be very brief. 1.12. What is the ratio of the Net enrolment rate(%) of Bhutan in 2001 to that in 2005?
Your answer should be very brief. 0.82. What is the ratio of the Net enrolment rate(%) of Lesotho in 2001 to that in 2005?
Offer a terse response. 1.05. What is the ratio of the Net enrolment rate(%) in Namibia in 2001 to that in 2005?
Your answer should be compact. 1.01. What is the ratio of the Net enrolment rate(%) of Paraguay in 2001 to that in 2005?
Ensure brevity in your answer.  1.03. What is the ratio of the Net enrolment rate(%) in Bhutan in 2001 to that in 2006?
Keep it short and to the point. 0.77. What is the ratio of the Net enrolment rate(%) in Lesotho in 2001 to that in 2006?
Provide a short and direct response. 1.05. What is the ratio of the Net enrolment rate(%) in Namibia in 2001 to that in 2006?
Offer a terse response. 1.03. What is the ratio of the Net enrolment rate(%) in Paraguay in 2001 to that in 2006?
Give a very brief answer. 1.05. What is the ratio of the Net enrolment rate(%) of Bhutan in 2001 to that in 2008?
Provide a short and direct response. 0.72. What is the ratio of the Net enrolment rate(%) in Lesotho in 2001 to that in 2008?
Your response must be concise. 1.08. What is the ratio of the Net enrolment rate(%) of Namibia in 2001 to that in 2008?
Your answer should be compact. 1.03. What is the ratio of the Net enrolment rate(%) of Paraguay in 2001 to that in 2008?
Your response must be concise. 1.11. What is the ratio of the Net enrolment rate(%) of Bhutan in 2005 to that in 2006?
Provide a short and direct response. 0.95. What is the ratio of the Net enrolment rate(%) of Namibia in 2005 to that in 2006?
Keep it short and to the point. 1.02. What is the ratio of the Net enrolment rate(%) in Paraguay in 2005 to that in 2006?
Offer a very short reply. 1.02. What is the ratio of the Net enrolment rate(%) of Bhutan in 2005 to that in 2008?
Make the answer very short. 0.88. What is the ratio of the Net enrolment rate(%) of Lesotho in 2005 to that in 2008?
Your answer should be very brief. 1.02. What is the ratio of the Net enrolment rate(%) in Namibia in 2005 to that in 2008?
Make the answer very short. 1.02. What is the ratio of the Net enrolment rate(%) of Paraguay in 2005 to that in 2008?
Keep it short and to the point. 1.08. What is the ratio of the Net enrolment rate(%) of Bhutan in 2006 to that in 2008?
Make the answer very short. 0.93. What is the ratio of the Net enrolment rate(%) in Lesotho in 2006 to that in 2008?
Offer a terse response. 1.02. What is the ratio of the Net enrolment rate(%) of Paraguay in 2006 to that in 2008?
Ensure brevity in your answer.  1.06. What is the difference between the highest and the second highest Net enrolment rate(%) in Bhutan?
Give a very brief answer. 6.11. What is the difference between the highest and the second highest Net enrolment rate(%) in Lesotho?
Your response must be concise. 0.04. What is the difference between the highest and the second highest Net enrolment rate(%) in Namibia?
Give a very brief answer. 0.37. What is the difference between the highest and the second highest Net enrolment rate(%) of Paraguay?
Your answer should be compact. 0.42. What is the difference between the highest and the lowest Net enrolment rate(%) in Bhutan?
Provide a succinct answer. 30.54. What is the difference between the highest and the lowest Net enrolment rate(%) of Lesotho?
Your answer should be compact. 20.48. What is the difference between the highest and the lowest Net enrolment rate(%) in Namibia?
Keep it short and to the point. 2.48. What is the difference between the highest and the lowest Net enrolment rate(%) in Paraguay?
Offer a terse response. 10.38. 